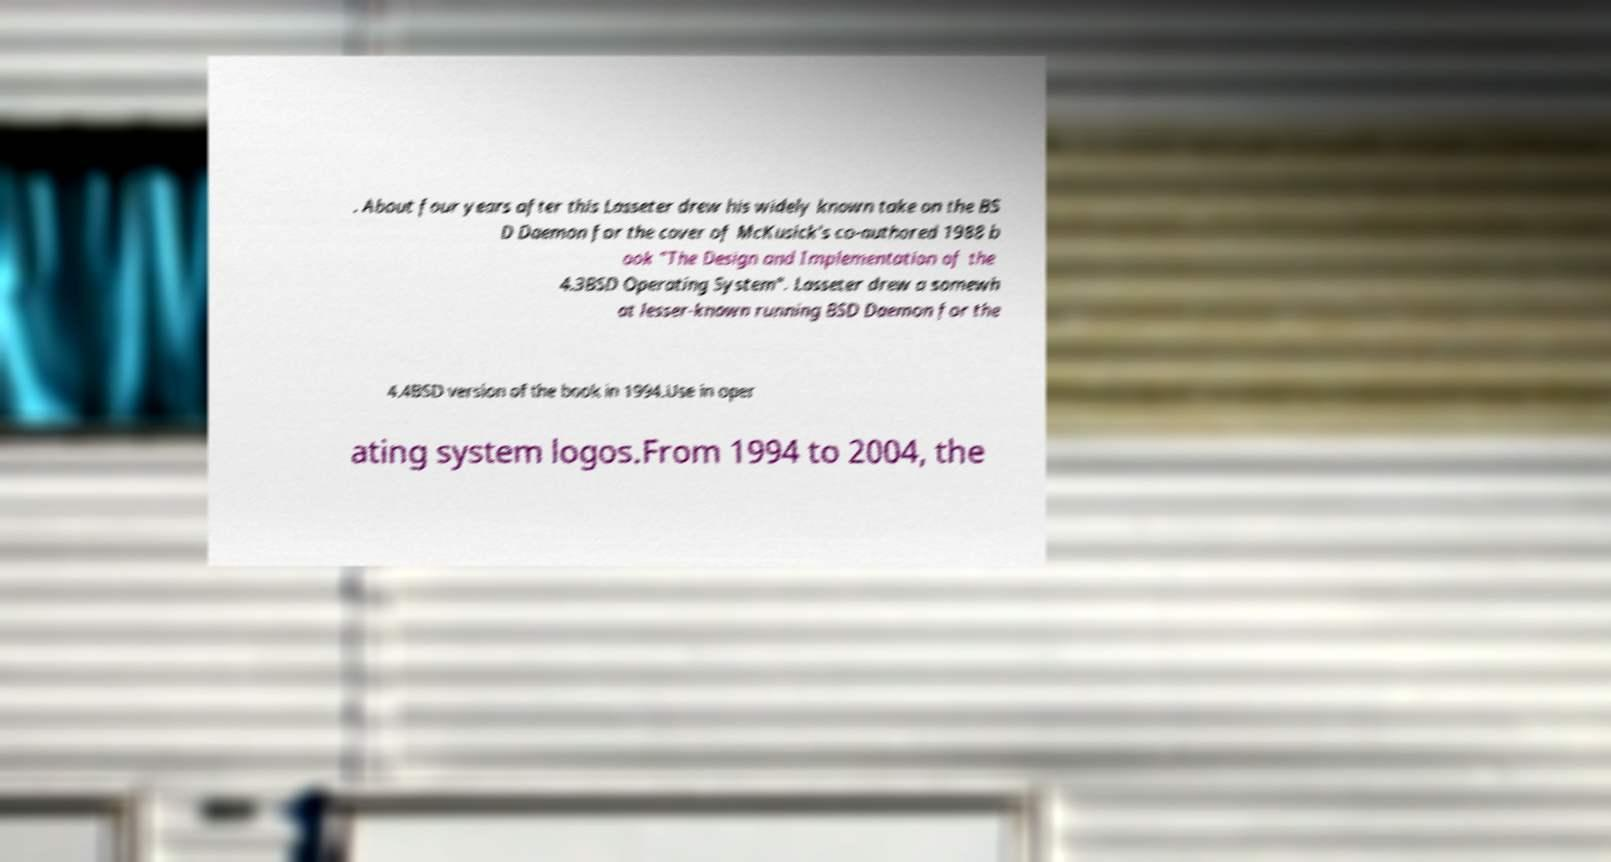Please read and relay the text visible in this image. What does it say? . About four years after this Lasseter drew his widely known take on the BS D Daemon for the cover of McKusick's co-authored 1988 b ook "The Design and Implementation of the 4.3BSD Operating System". Lasseter drew a somewh at lesser-known running BSD Daemon for the 4.4BSD version of the book in 1994.Use in oper ating system logos.From 1994 to 2004, the 